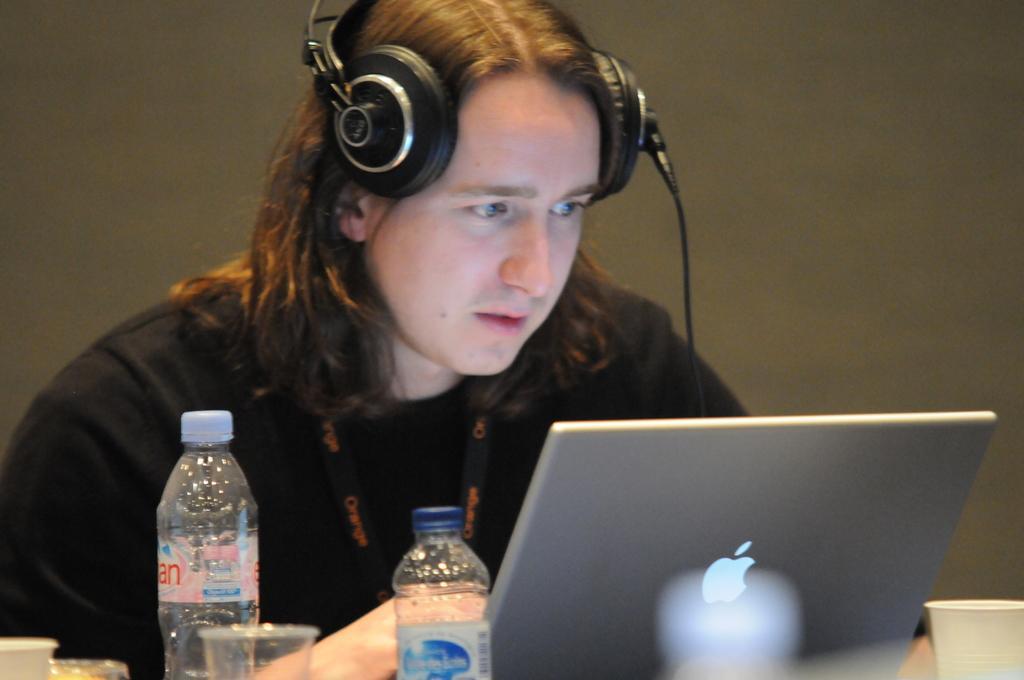Describe this image in one or two sentences. There is a man wearing black shirt and putting headset on his head. I can see a laptop,paper cup,water bottle,and plastic glass placed on it. 